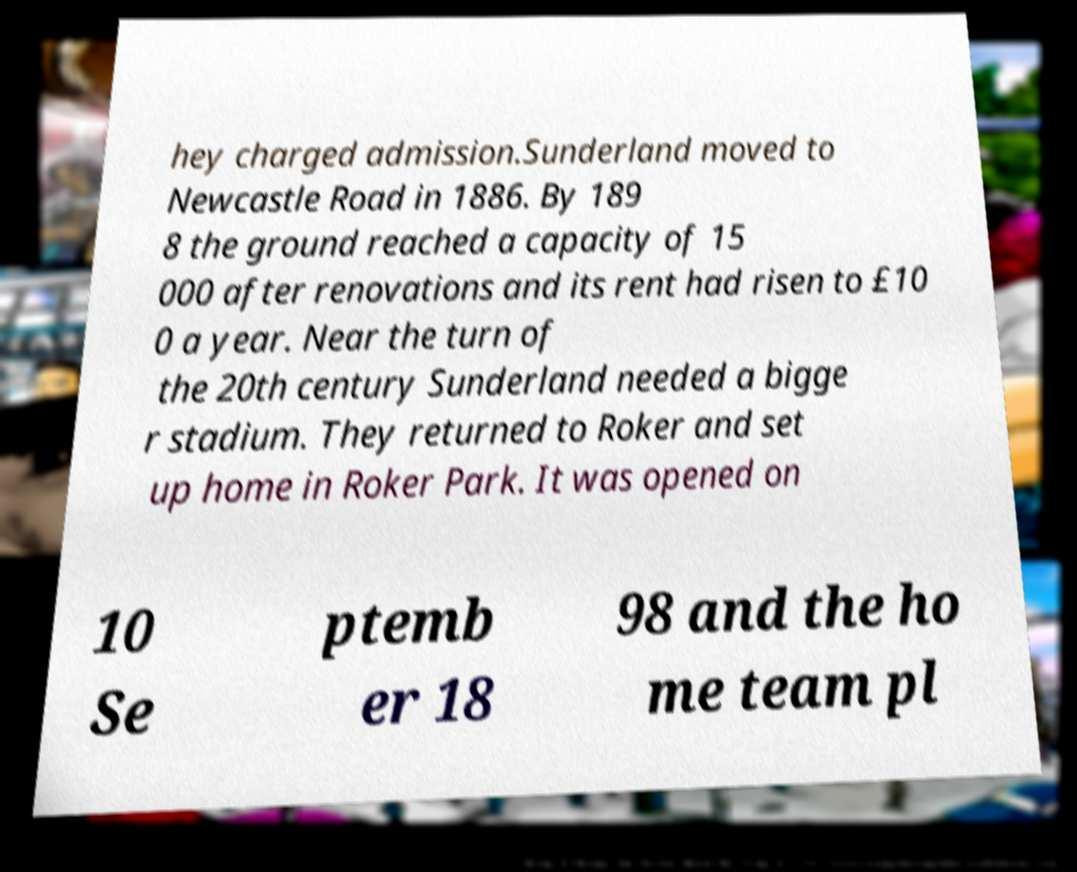Can you accurately transcribe the text from the provided image for me? hey charged admission.Sunderland moved to Newcastle Road in 1886. By 189 8 the ground reached a capacity of 15 000 after renovations and its rent had risen to £10 0 a year. Near the turn of the 20th century Sunderland needed a bigge r stadium. They returned to Roker and set up home in Roker Park. It was opened on 10 Se ptemb er 18 98 and the ho me team pl 